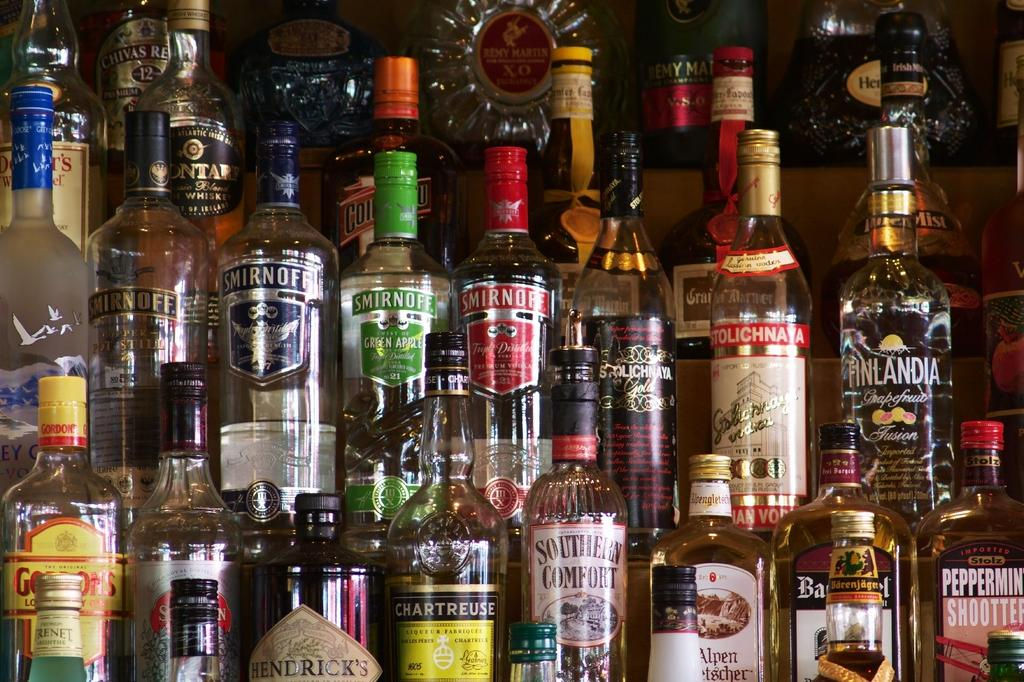What objects are visible in the image? There are bottles in the image. Where are the bottles located? The bottles are on a shelf. What type of pollution is being caused by the bottles in the image? There is no indication of pollution in the image; it only shows bottles on a shelf. Can you tell me who the partner is in the image? There is no reference to a partner or any people in the image; it only shows bottles on a shelf. 